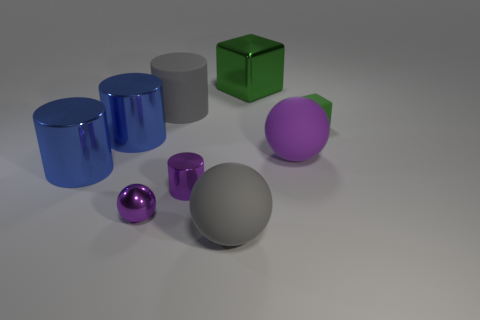What number of tiny shiny cylinders have the same color as the large matte cylinder?
Make the answer very short. 0. Does the purple matte object have the same shape as the small green matte thing?
Ensure brevity in your answer.  No. What is the size of the purple ball on the right side of the gray matte thing behind the purple shiny ball?
Give a very brief answer. Large. Is there a rubber cylinder that has the same size as the rubber block?
Make the answer very short. No. Is the size of the green matte object that is right of the large purple matte thing the same as the matte thing that is in front of the small purple metallic ball?
Make the answer very short. No. There is a small shiny object behind the small object left of the gray matte cylinder; what is its shape?
Ensure brevity in your answer.  Cylinder. There is a tiny matte block; how many tiny cylinders are on the left side of it?
Offer a very short reply. 1. There is a big cylinder that is made of the same material as the small green object; what color is it?
Offer a very short reply. Gray. Do the gray rubber cylinder and the purple object that is to the right of the big shiny block have the same size?
Your response must be concise. Yes. How big is the purple ball that is right of the large matte object in front of the ball right of the gray matte sphere?
Make the answer very short. Large. 